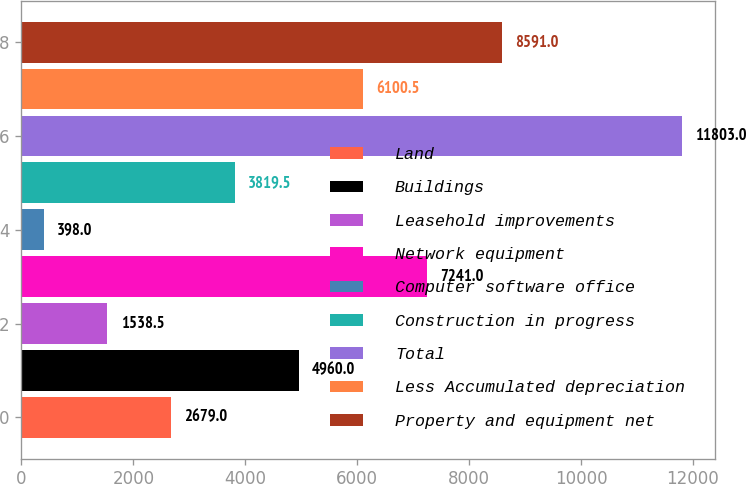Convert chart to OTSL. <chart><loc_0><loc_0><loc_500><loc_500><bar_chart><fcel>Land<fcel>Buildings<fcel>Leasehold improvements<fcel>Network equipment<fcel>Computer software office<fcel>Construction in progress<fcel>Total<fcel>Less Accumulated depreciation<fcel>Property and equipment net<nl><fcel>2679<fcel>4960<fcel>1538.5<fcel>7241<fcel>398<fcel>3819.5<fcel>11803<fcel>6100.5<fcel>8591<nl></chart> 